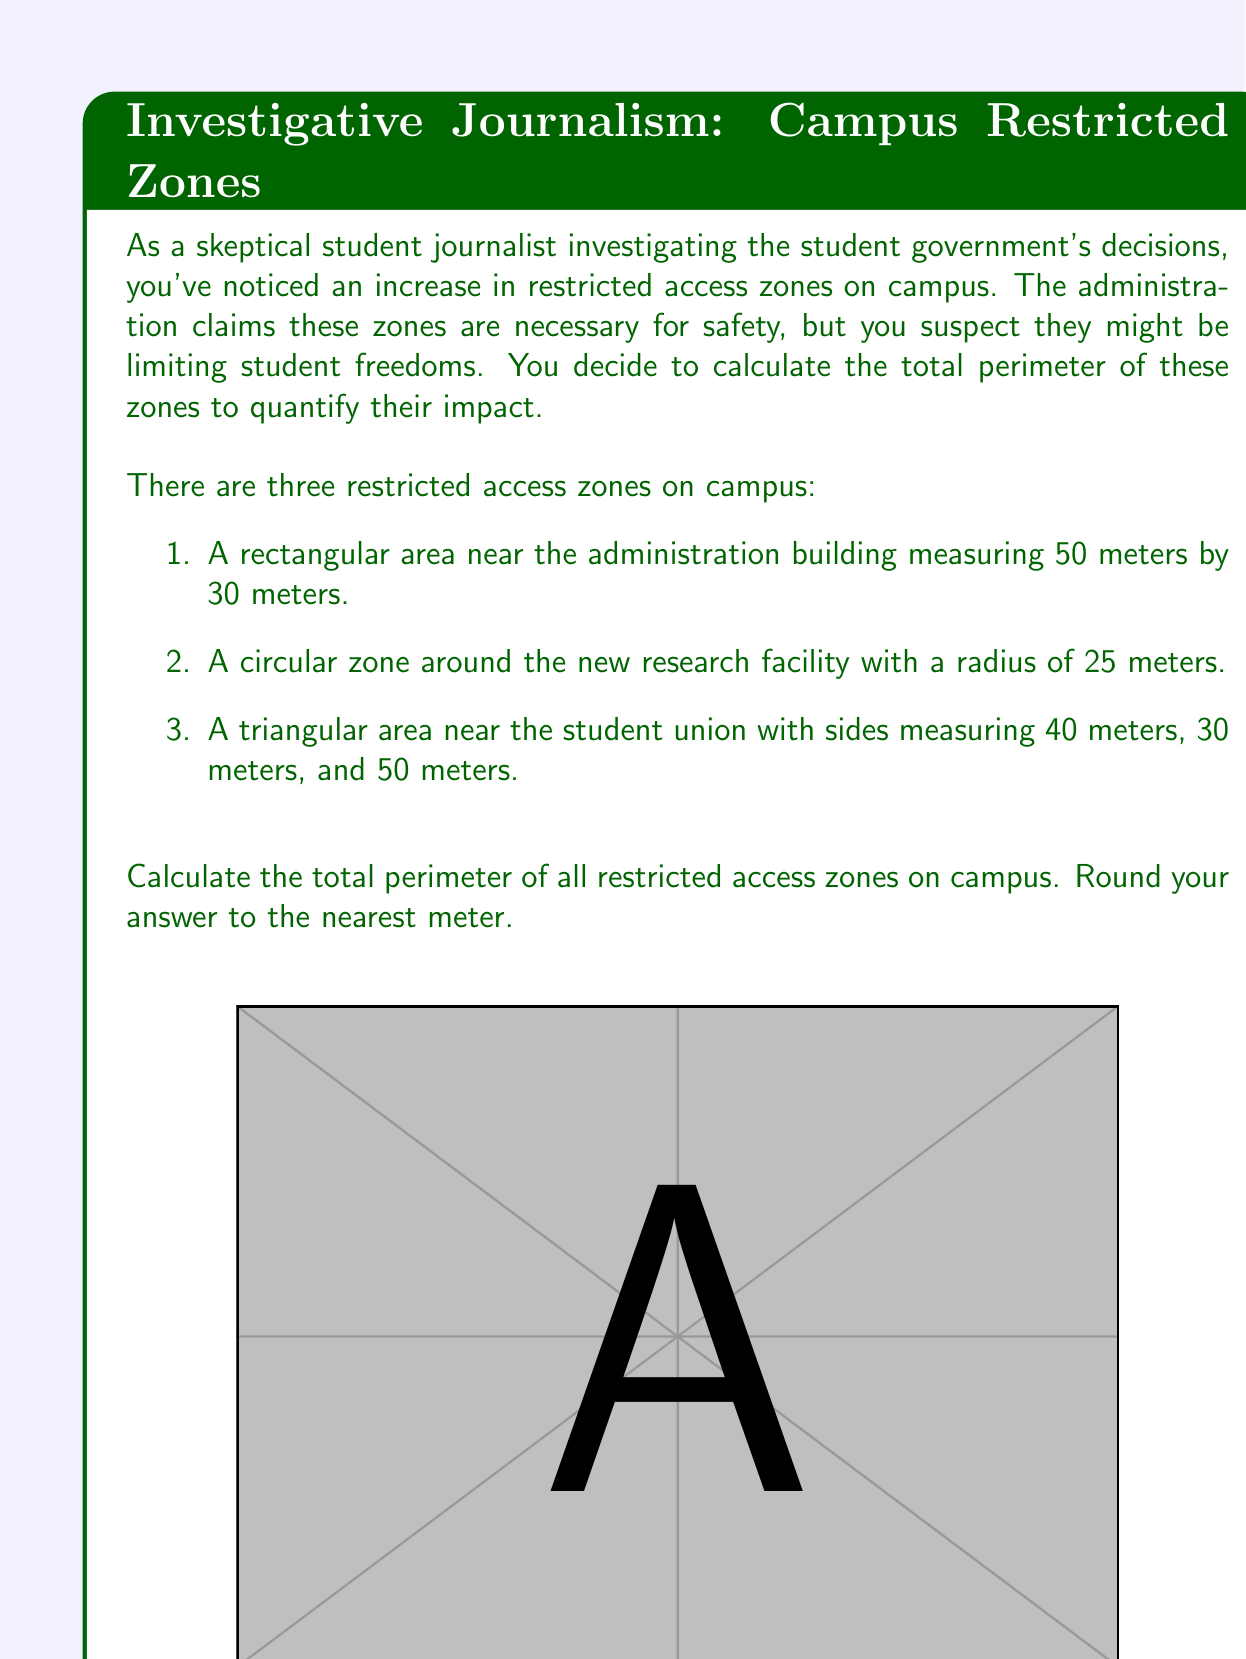Can you answer this question? Let's calculate the perimeter of each zone separately:

1. Rectangular area (Administration building):
   Perimeter = $2(length + width)$
   $$ P_1 = 2(50m + 30m) = 2(80m) = 160m $$

2. Circular zone (Research facility):
   Perimeter (circumference) = $2\pi r$
   $$ P_2 = 2\pi(25m) \approx 157.08m $$

3. Triangular area (Student union):
   Perimeter = sum of all sides
   $$ P_3 = 40m + 30m + 50m = 120m $$

Now, we sum up all the perimeters:

$$ \text{Total Perimeter} = P_1 + P_2 + P_3 $$
$$ \text{Total Perimeter} = 160m + 157.08m + 120m = 437.08m $$

Rounding to the nearest meter:
$$ \text{Total Perimeter} \approx 437m $$
Answer: The total perimeter of all restricted access zones on campus is approximately 437 meters. 